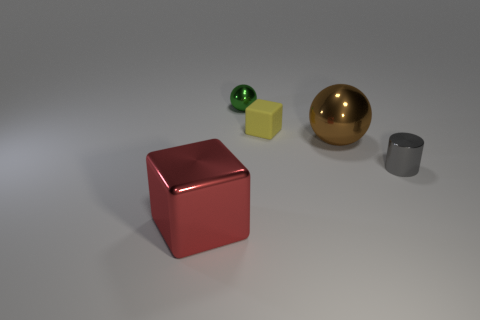Add 1 yellow cubes. How many objects exist? 6 Subtract all blocks. How many objects are left? 3 Add 5 gray cylinders. How many gray cylinders are left? 6 Add 5 blue metal cylinders. How many blue metal cylinders exist? 5 Subtract 0 gray cubes. How many objects are left? 5 Subtract all small yellow matte objects. Subtract all metallic cylinders. How many objects are left? 3 